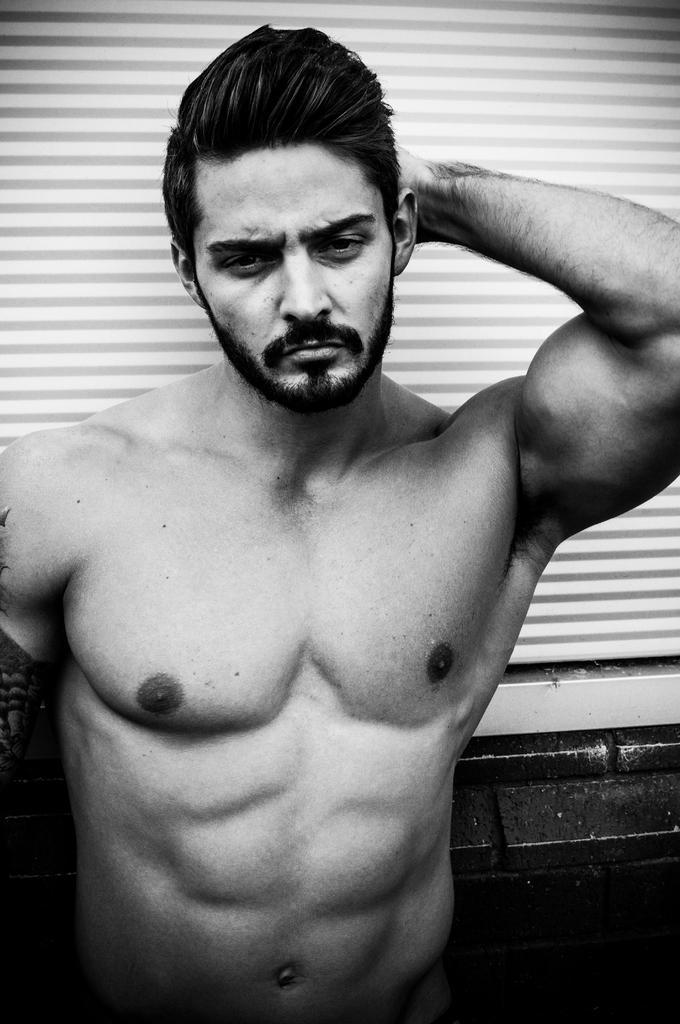Could you give a brief overview of what you see in this image? This image is a black and white image. In the middle of the image there is a man standing on the floor. In the background there is a blind. 